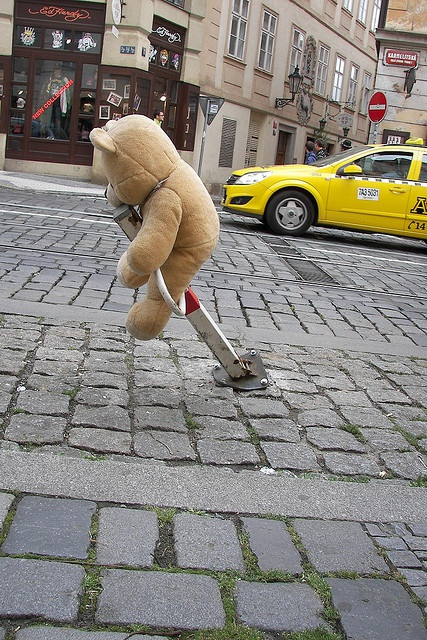Describe the objects in this image and their specific colors. I can see teddy bear in darkgray, tan, gray, and maroon tones, car in darkgray, gold, black, and olive tones, people in darkgray, black, and gray tones, people in darkgray, black, gray, khaki, and lightpink tones, and people in darkgray, black, and gray tones in this image. 